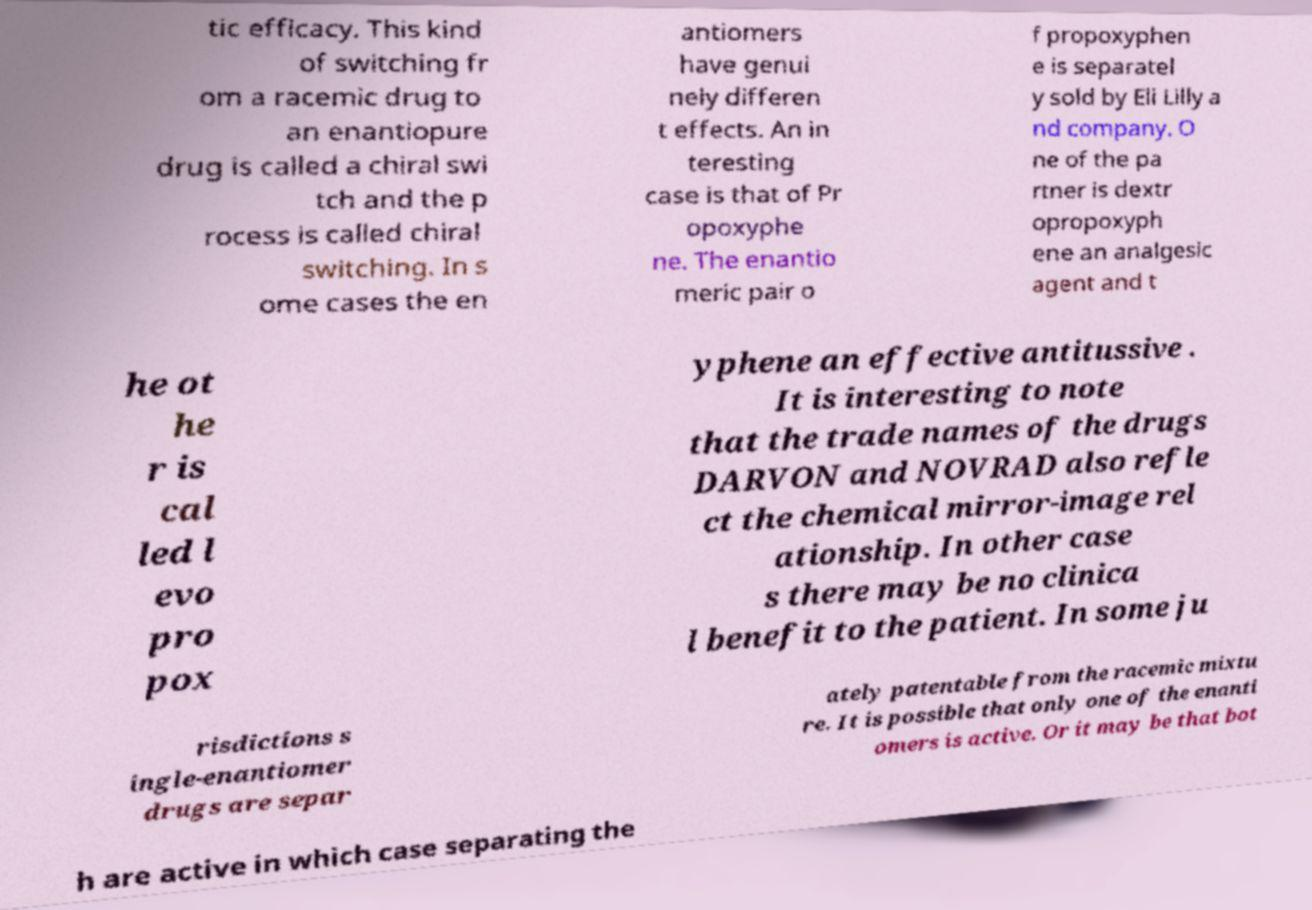I need the written content from this picture converted into text. Can you do that? tic efficacy. This kind of switching fr om a racemic drug to an enantiopure drug is called a chiral swi tch and the p rocess is called chiral switching. In s ome cases the en antiomers have genui nely differen t effects. An in teresting case is that of Pr opoxyphe ne. The enantio meric pair o f propoxyphen e is separatel y sold by Eli Lilly a nd company. O ne of the pa rtner is dextr opropoxyph ene an analgesic agent and t he ot he r is cal led l evo pro pox yphene an effective antitussive . It is interesting to note that the trade names of the drugs DARVON and NOVRAD also refle ct the chemical mirror-image rel ationship. In other case s there may be no clinica l benefit to the patient. In some ju risdictions s ingle-enantiomer drugs are separ ately patentable from the racemic mixtu re. It is possible that only one of the enanti omers is active. Or it may be that bot h are active in which case separating the 